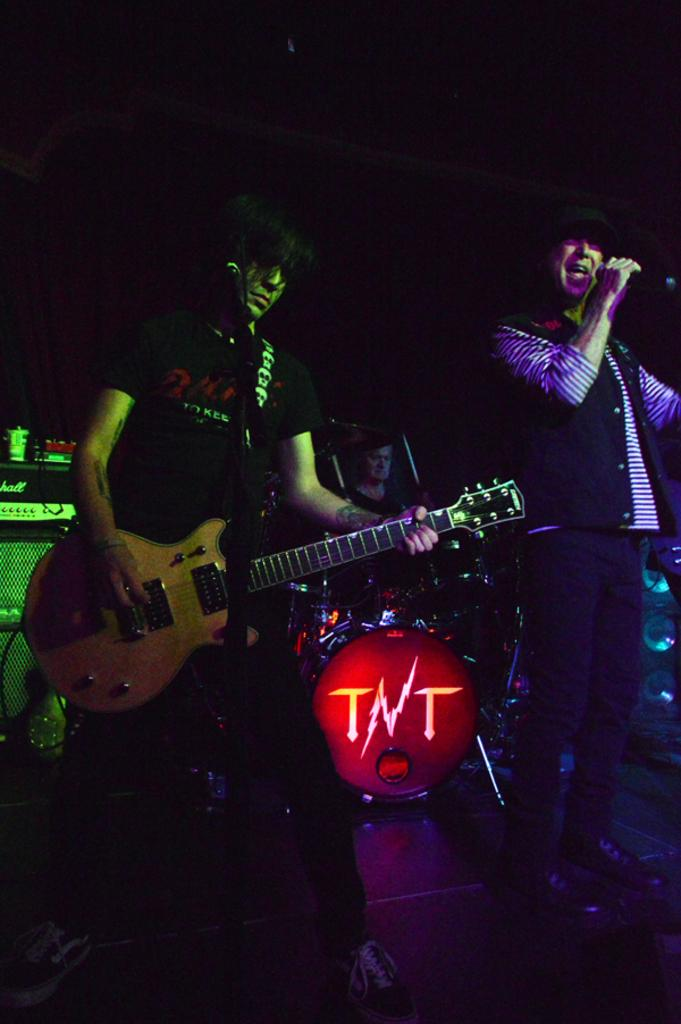What is the man in the image doing? The man is standing in the image and holding a guitar. Can you describe another person in the image? There is a person holding a microphone in the image. What is happening in the background of the image? There is a man playing a drum set in the background. How many cows are visible in the image? There are no cows present in the image. What is the limit of the elbow's movement in the image? The image does not show any elbows or their movements, so it is not possible to determine a limit. 